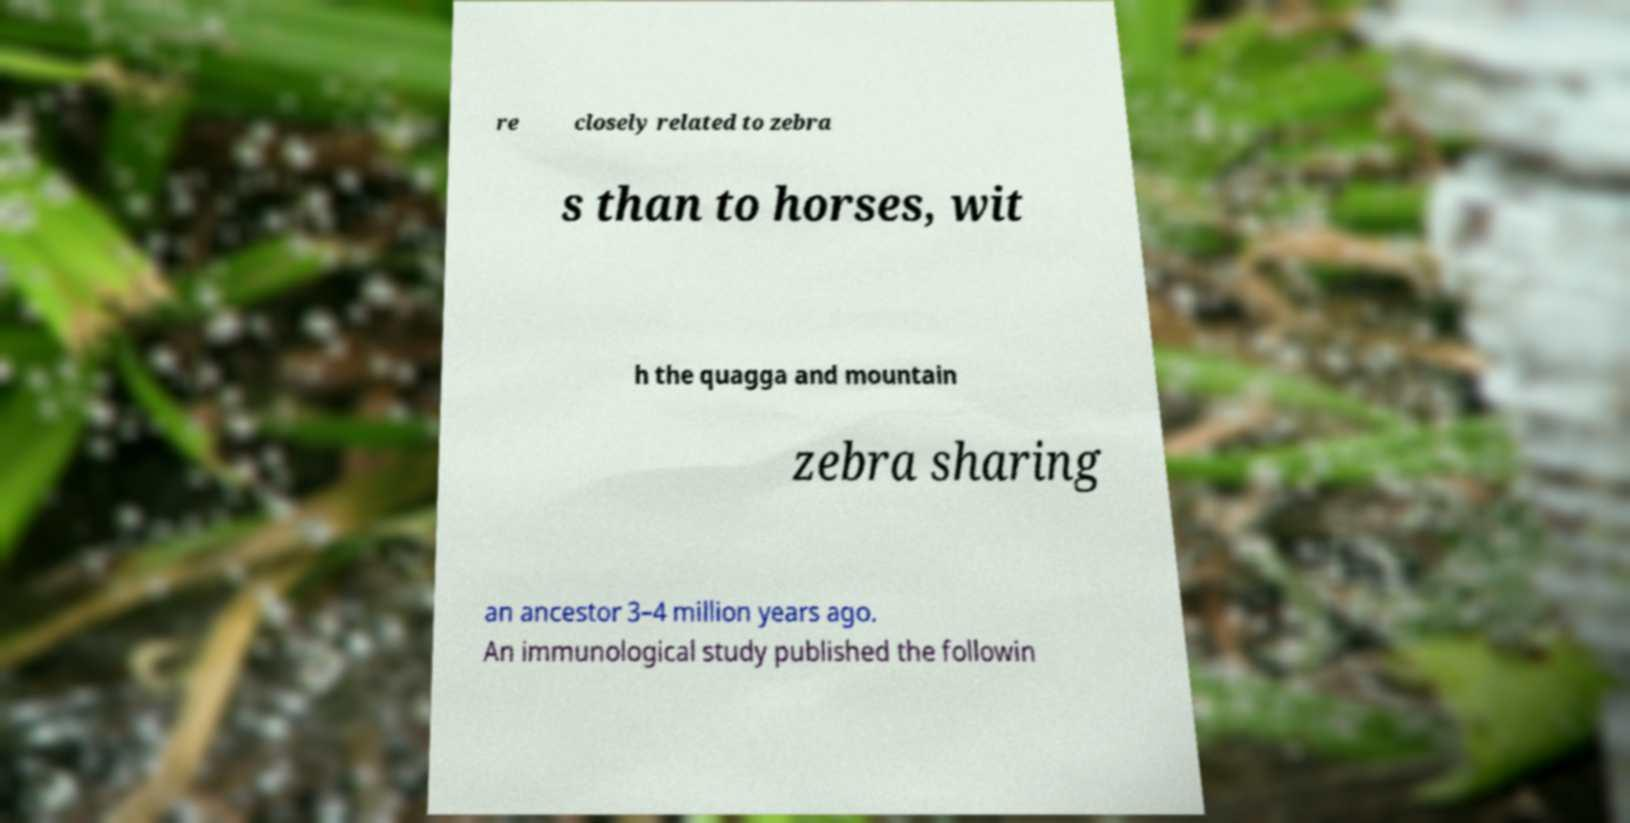For documentation purposes, I need the text within this image transcribed. Could you provide that? re closely related to zebra s than to horses, wit h the quagga and mountain zebra sharing an ancestor 3–4 million years ago. An immunological study published the followin 